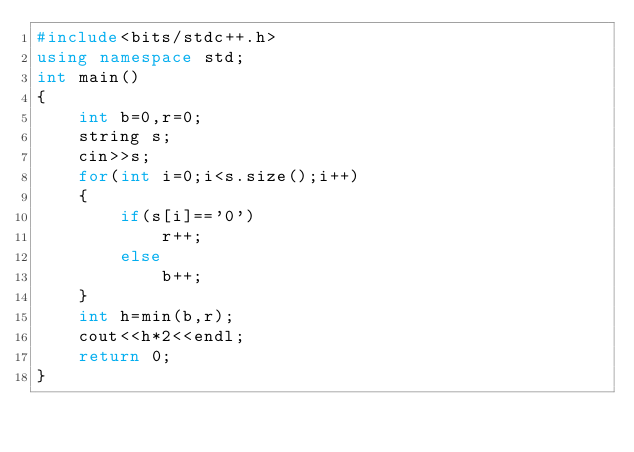Convert code to text. <code><loc_0><loc_0><loc_500><loc_500><_C++_>#include<bits/stdc++.h>
using namespace std;
int main()
{
    int b=0,r=0;
    string s;
    cin>>s;
    for(int i=0;i<s.size();i++)
    {
        if(s[i]=='0')
            r++;
        else
            b++;
    }
    int h=min(b,r);
    cout<<h*2<<endl;
    return 0;
}
</code> 